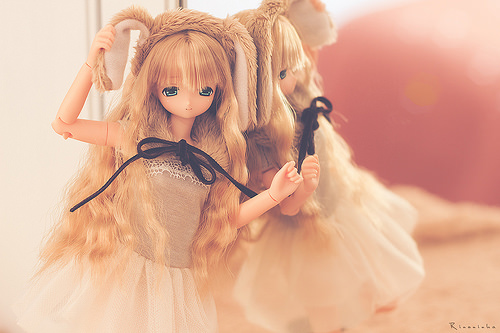<image>
Can you confirm if the doll is behind the mirror? No. The doll is not behind the mirror. From this viewpoint, the doll appears to be positioned elsewhere in the scene. 